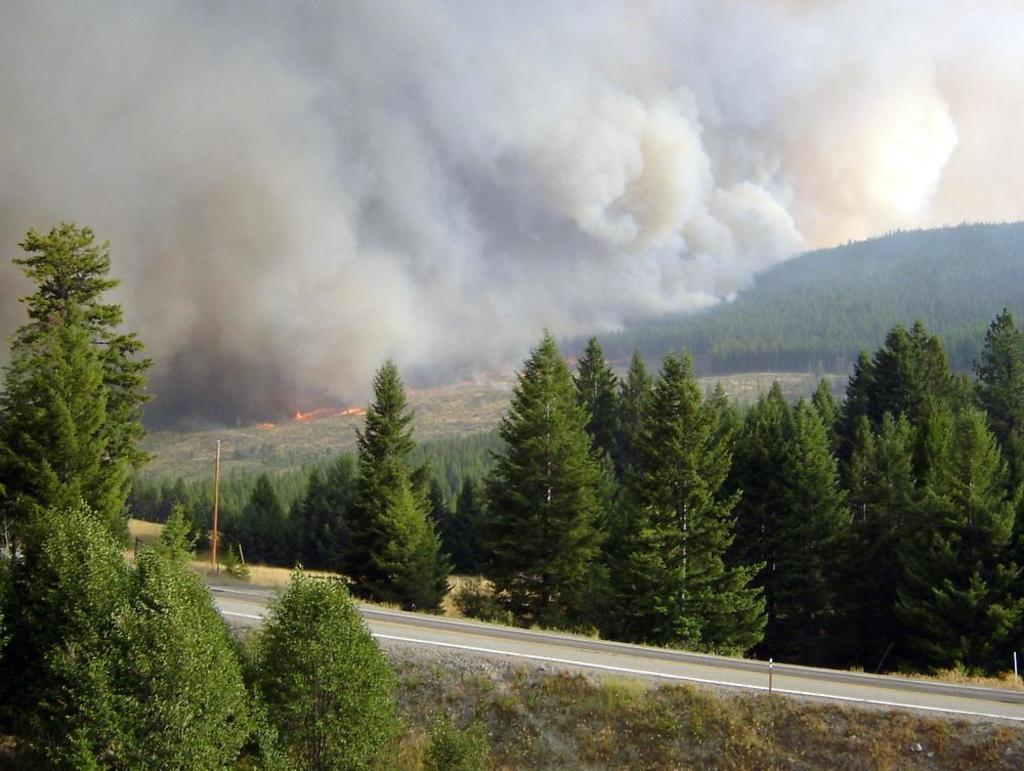What is located at the bottom of the image? There are trees and poles at the bottom of the image. What can be seen at the top of the image? The sky is visible at the top of the image. What environmental issue is depicted in the image? There is air pollution in the image. How many pets are visible in the image? There are no pets present in the image. What type of loss is depicted in the image? There is no loss depicted in the image; it features trees, poles, and air pollution. 